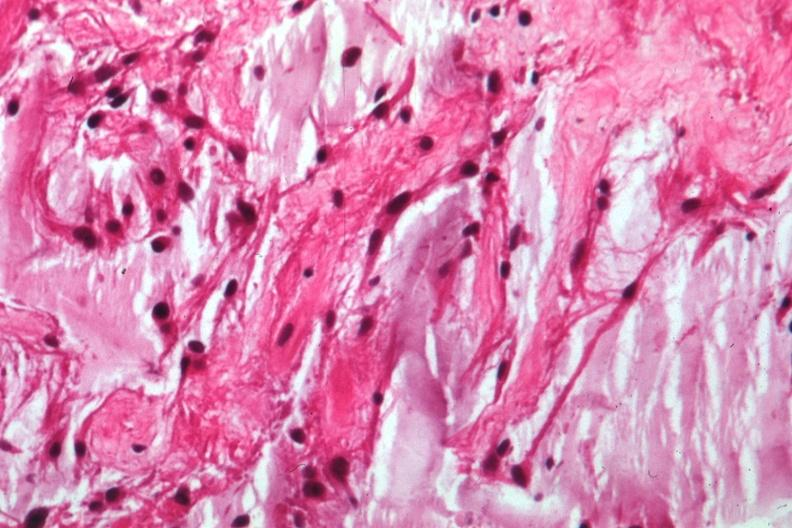what does this image show?
Answer the question using a single word or phrase. Glioma 